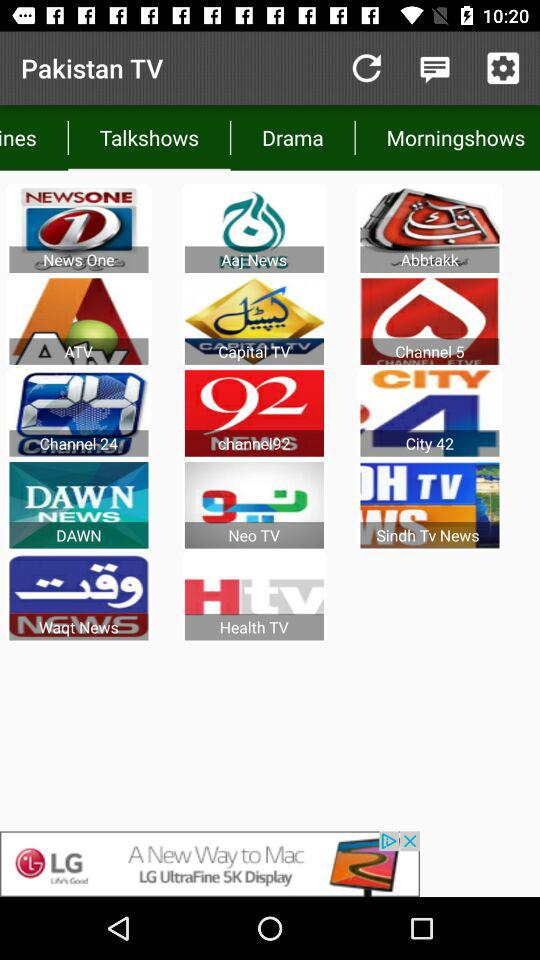What is the application name? The application name is "Pakistan TV". 